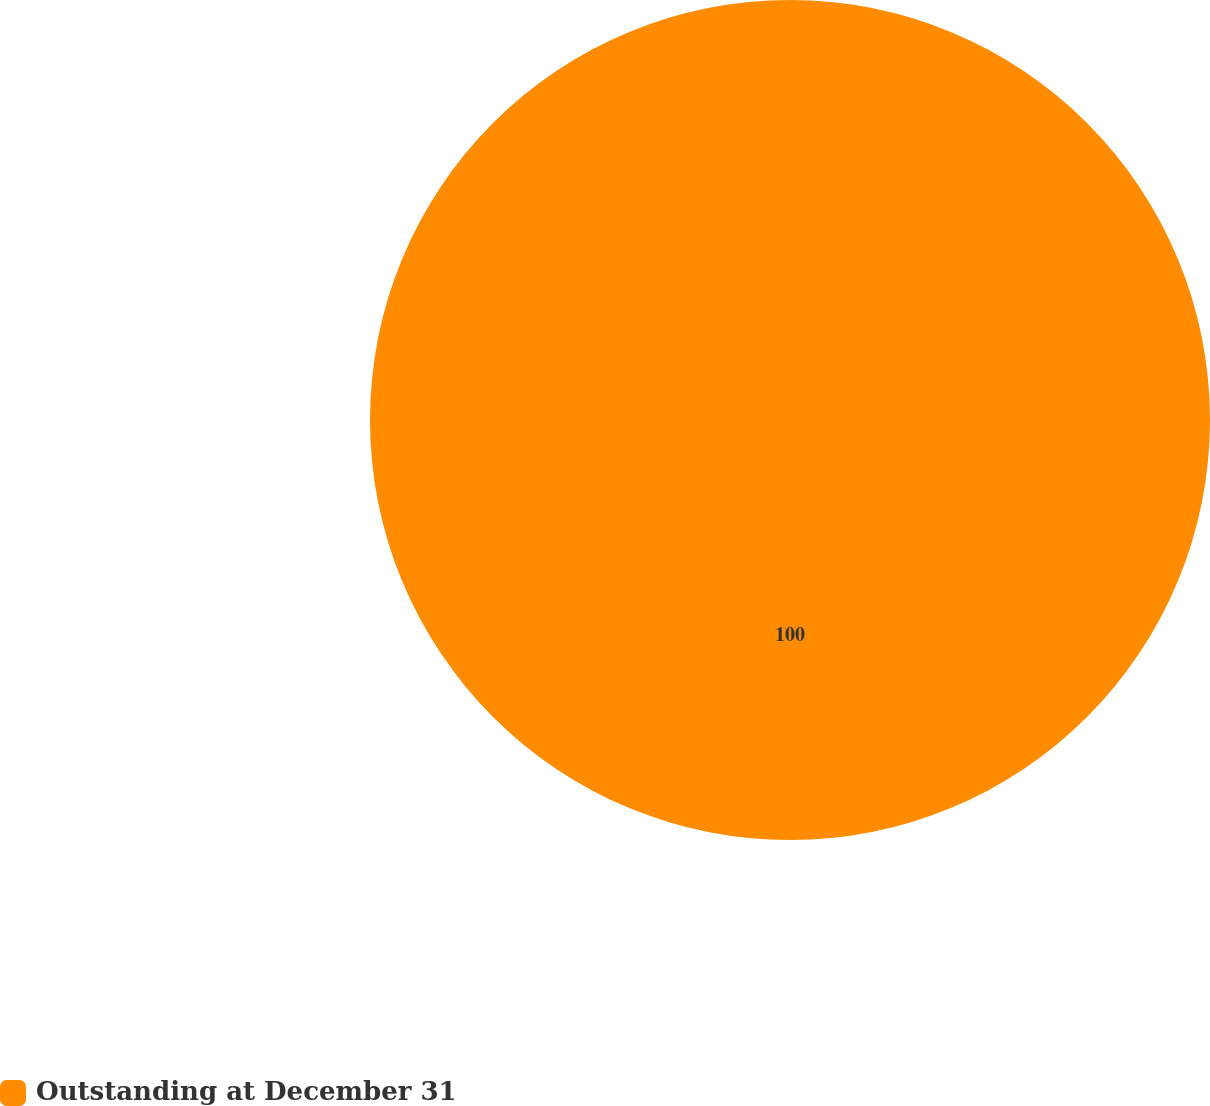Convert chart to OTSL. <chart><loc_0><loc_0><loc_500><loc_500><pie_chart><fcel>Outstanding at December 31<nl><fcel>100.0%<nl></chart> 